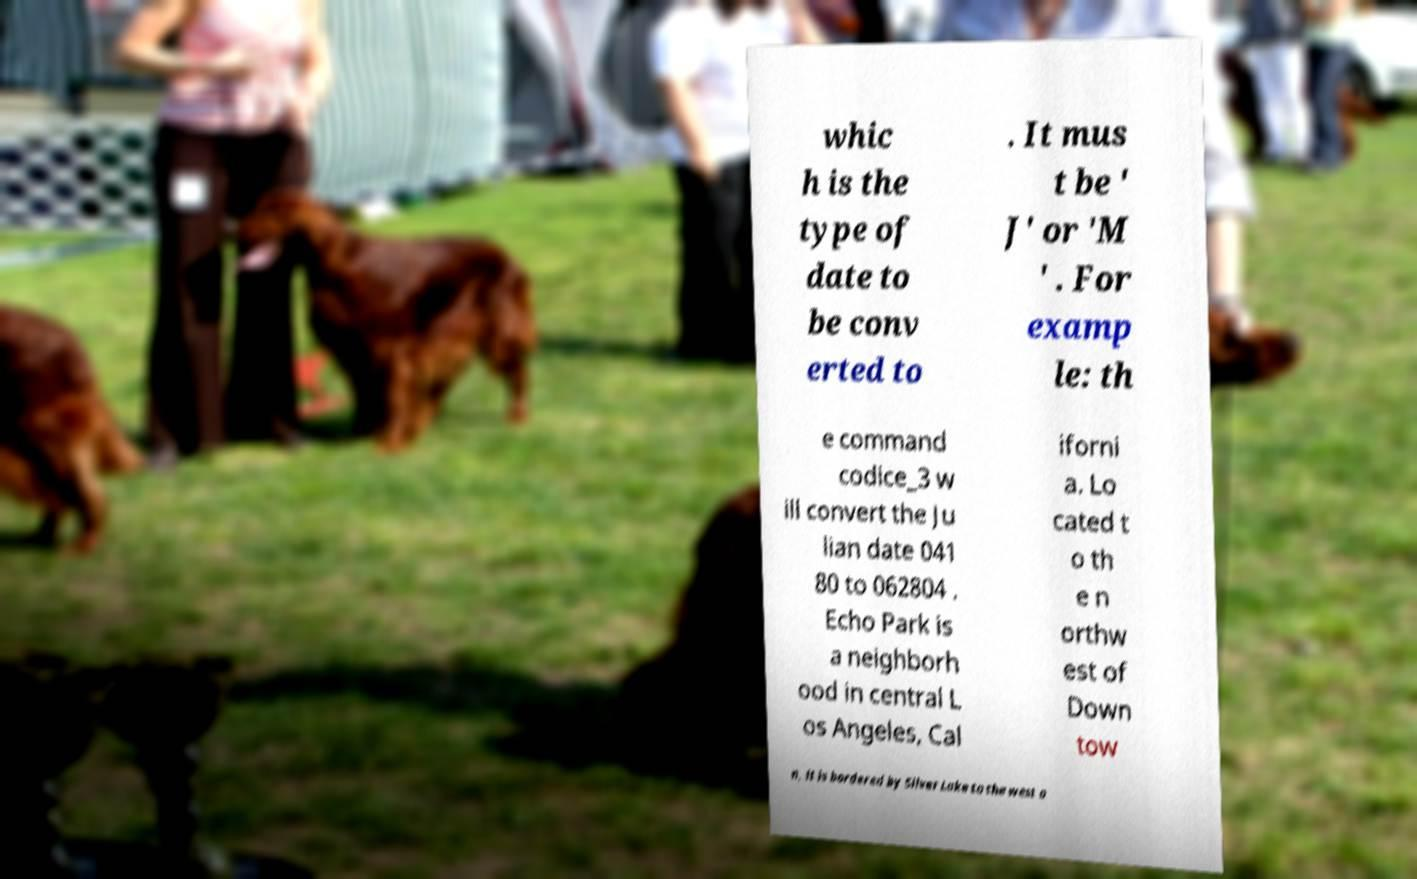Could you extract and type out the text from this image? whic h is the type of date to be conv erted to . It mus t be ' J' or 'M ' . For examp le: th e command codice_3 w ill convert the Ju lian date 041 80 to 062804 . Echo Park is a neighborh ood in central L os Angeles, Cal iforni a. Lo cated t o th e n orthw est of Down tow n, it is bordered by Silver Lake to the west a 